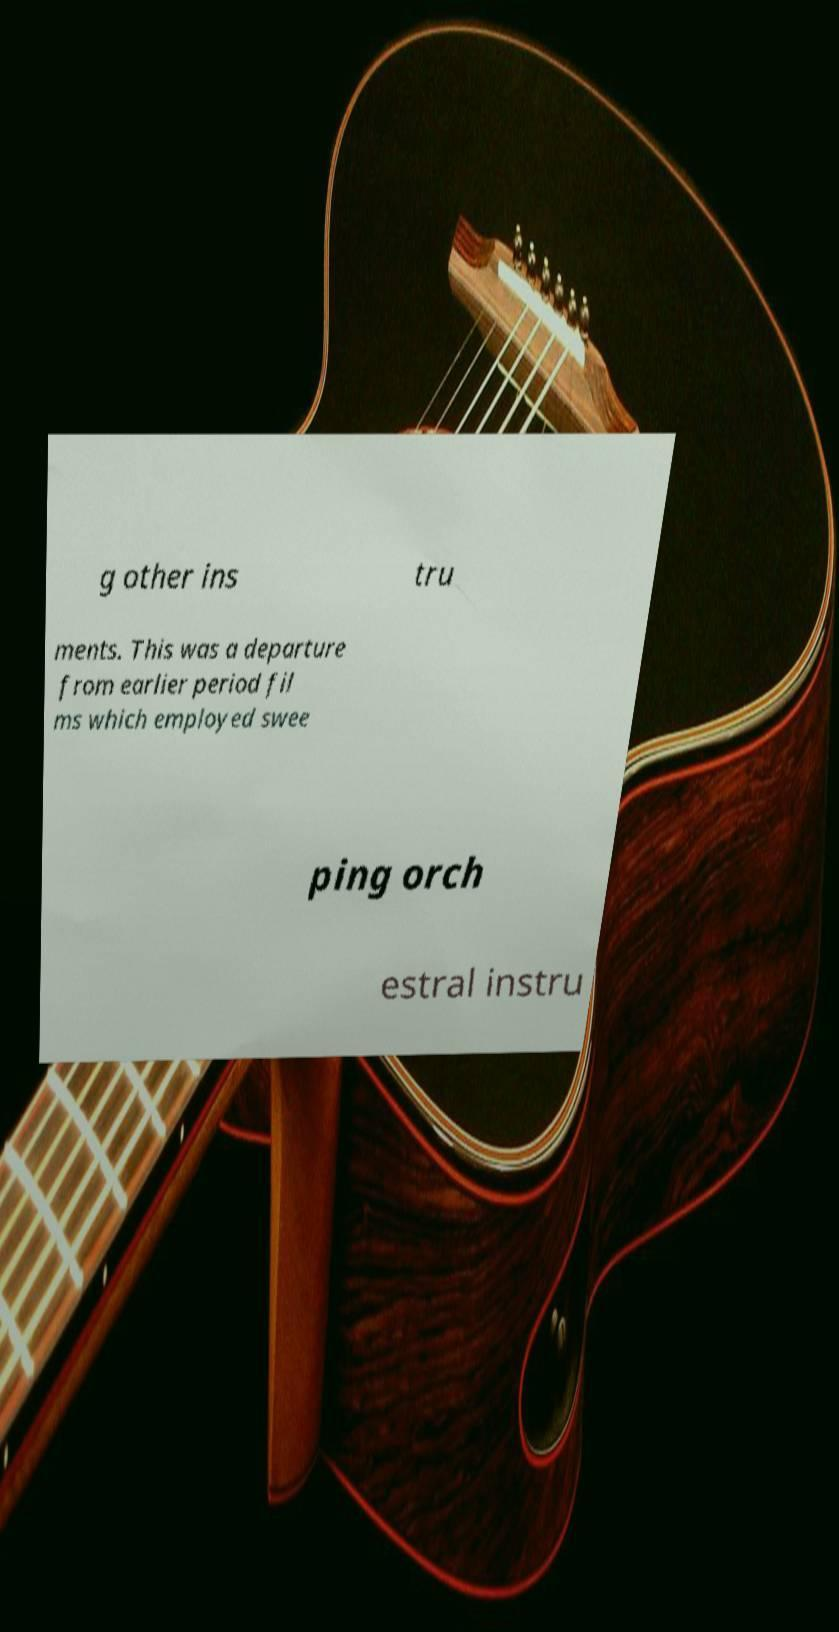Can you read and provide the text displayed in the image?This photo seems to have some interesting text. Can you extract and type it out for me? g other ins tru ments. This was a departure from earlier period fil ms which employed swee ping orch estral instru 